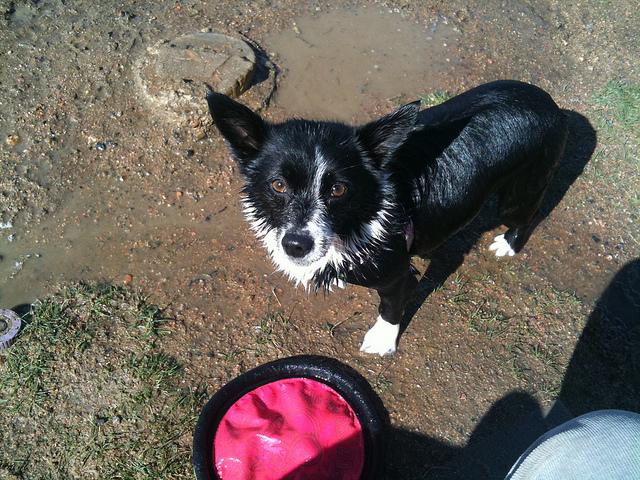What color is the dog?
Give a very brief answer. Black. What kind of dog is this?
Write a very short answer. Mutt. Is the dog playing in the dirt?
Keep it brief. Yes. What is the dog looking at?
Be succinct. Camera. 